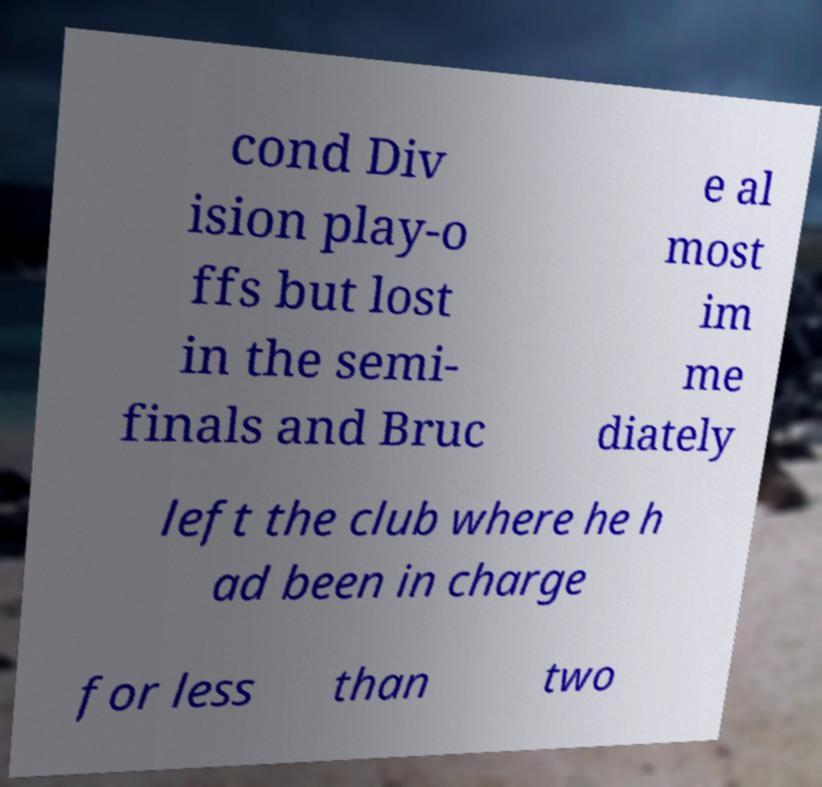Can you read and provide the text displayed in the image?This photo seems to have some interesting text. Can you extract and type it out for me? cond Div ision play-o ffs but lost in the semi- finals and Bruc e al most im me diately left the club where he h ad been in charge for less than two 